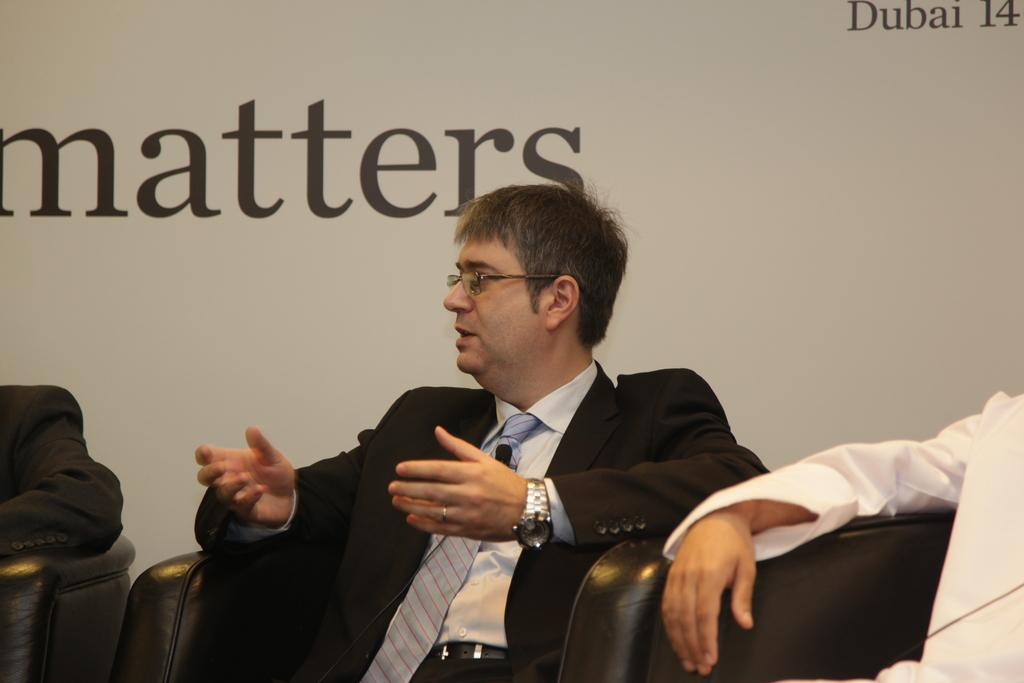How many people are in the image? There are three persons in the image. What are the persons doing in the image? The persons are sitting on chairs. Can you describe the appearance of one of the men? One of the men is wearing a blazer, spectacles, a tie, and a watch. What is the man doing in the image? The man is talking. What can be seen in the background of the image? There is a wall in the background of the image. What verse is the man reciting in the image? There is no indication in the image that the man is reciting a verse, so it cannot be determined from the picture. 